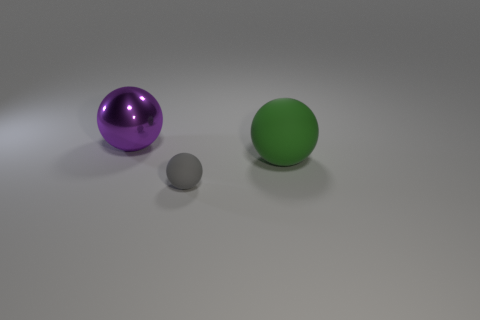Is there anything else that has the same material as the large purple ball?
Provide a short and direct response. No. There is a ball in front of the large green matte object; are there any gray rubber objects behind it?
Offer a terse response. No. Is the number of tiny rubber objects behind the gray rubber sphere less than the number of large shiny spheres to the right of the big green object?
Offer a very short reply. No. Is there anything else that has the same size as the metallic thing?
Provide a short and direct response. Yes. The purple object is what shape?
Offer a very short reply. Sphere. There is a sphere left of the gray rubber object; what is it made of?
Give a very brief answer. Metal. What is the size of the rubber thing that is on the left side of the large object that is to the right of the large sphere that is behind the green matte sphere?
Your answer should be very brief. Small. Do the ball to the left of the small matte object and the big thing right of the small gray ball have the same material?
Keep it short and to the point. No. How many other things are there of the same color as the metal thing?
Your answer should be compact. 0. How many things are either big spheres that are on the left side of the big rubber object or balls behind the gray rubber object?
Your answer should be very brief. 2. 